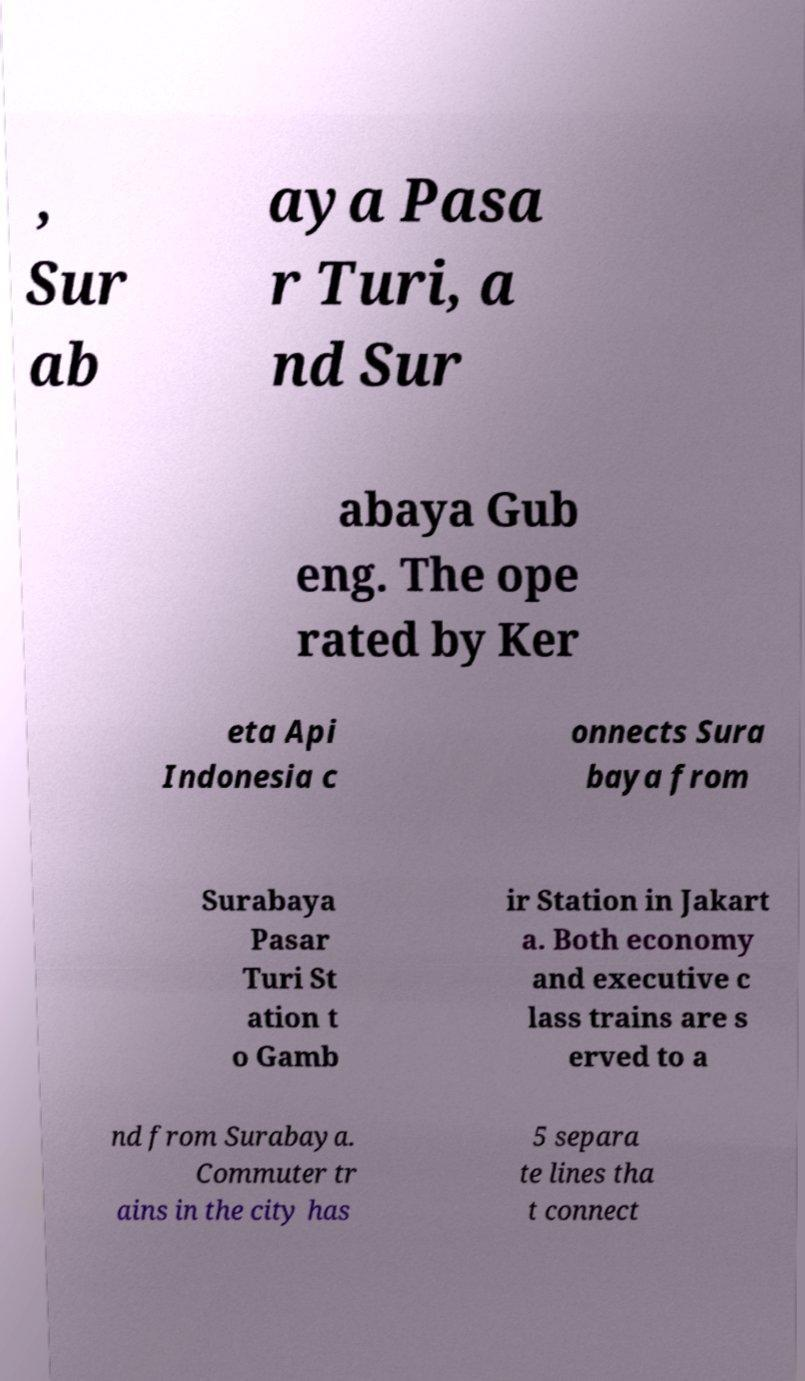Please read and relay the text visible in this image. What does it say? , Sur ab aya Pasa r Turi, a nd Sur abaya Gub eng. The ope rated by Ker eta Api Indonesia c onnects Sura baya from Surabaya Pasar Turi St ation t o Gamb ir Station in Jakart a. Both economy and executive c lass trains are s erved to a nd from Surabaya. Commuter tr ains in the city has 5 separa te lines tha t connect 